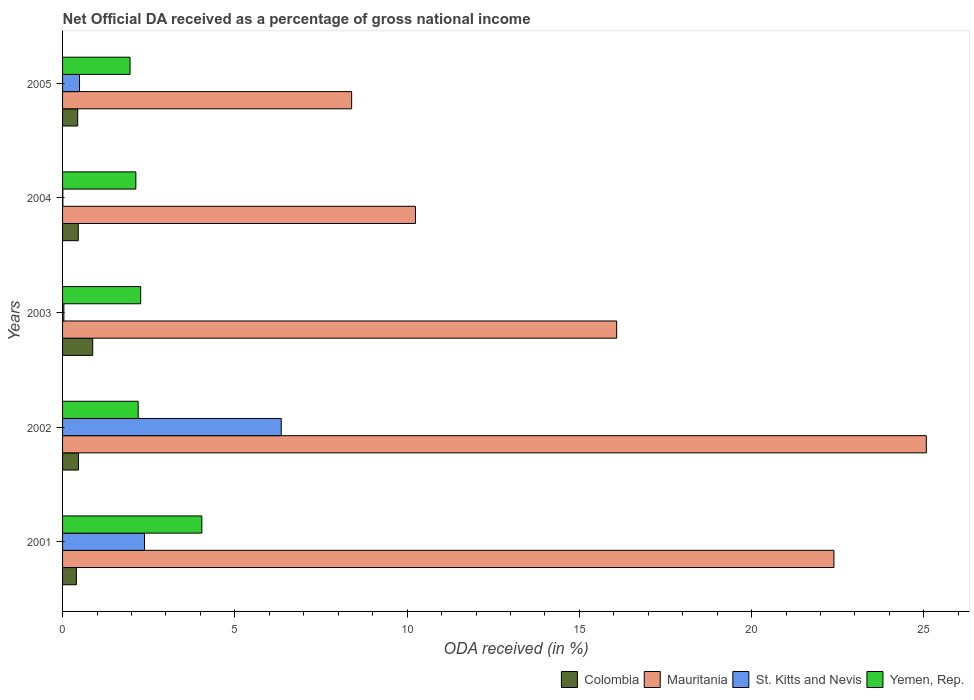How many different coloured bars are there?
Your answer should be very brief. 4. Are the number of bars per tick equal to the number of legend labels?
Provide a succinct answer. Yes. How many bars are there on the 3rd tick from the top?
Ensure brevity in your answer.  4. How many bars are there on the 4th tick from the bottom?
Your response must be concise. 4. What is the net official DA received in Yemen, Rep. in 2001?
Offer a very short reply. 4.04. Across all years, what is the maximum net official DA received in Mauritania?
Provide a succinct answer. 25.07. Across all years, what is the minimum net official DA received in Colombia?
Make the answer very short. 0.4. What is the total net official DA received in Colombia in the graph?
Offer a very short reply. 2.63. What is the difference between the net official DA received in Colombia in 2001 and that in 2002?
Keep it short and to the point. -0.06. What is the difference between the net official DA received in Mauritania in 2001 and the net official DA received in Yemen, Rep. in 2002?
Your answer should be very brief. 20.19. What is the average net official DA received in St. Kitts and Nevis per year?
Provide a succinct answer. 1.85. In the year 2005, what is the difference between the net official DA received in Mauritania and net official DA received in Yemen, Rep.?
Your answer should be compact. 6.43. What is the ratio of the net official DA received in Mauritania in 2001 to that in 2004?
Provide a succinct answer. 2.19. Is the difference between the net official DA received in Mauritania in 2004 and 2005 greater than the difference between the net official DA received in Yemen, Rep. in 2004 and 2005?
Your answer should be very brief. Yes. What is the difference between the highest and the second highest net official DA received in Yemen, Rep.?
Provide a succinct answer. 1.77. What is the difference between the highest and the lowest net official DA received in Mauritania?
Keep it short and to the point. 16.68. Is the sum of the net official DA received in St. Kitts and Nevis in 2003 and 2005 greater than the maximum net official DA received in Colombia across all years?
Ensure brevity in your answer.  No. What does the 4th bar from the top in 2005 represents?
Your response must be concise. Colombia. What does the 2nd bar from the bottom in 2003 represents?
Ensure brevity in your answer.  Mauritania. How many bars are there?
Provide a succinct answer. 20. Are the values on the major ticks of X-axis written in scientific E-notation?
Provide a succinct answer. No. Does the graph contain any zero values?
Your answer should be compact. No. Does the graph contain grids?
Provide a short and direct response. No. What is the title of the graph?
Give a very brief answer. Net Official DA received as a percentage of gross national income. Does "Sint Maarten (Dutch part)" appear as one of the legend labels in the graph?
Keep it short and to the point. No. What is the label or title of the X-axis?
Give a very brief answer. ODA received (in %). What is the label or title of the Y-axis?
Give a very brief answer. Years. What is the ODA received (in %) in Colombia in 2001?
Your answer should be very brief. 0.4. What is the ODA received (in %) in Mauritania in 2001?
Ensure brevity in your answer.  22.39. What is the ODA received (in %) of St. Kitts and Nevis in 2001?
Make the answer very short. 2.38. What is the ODA received (in %) of Yemen, Rep. in 2001?
Give a very brief answer. 4.04. What is the ODA received (in %) of Colombia in 2002?
Your answer should be compact. 0.46. What is the ODA received (in %) in Mauritania in 2002?
Provide a short and direct response. 25.07. What is the ODA received (in %) in St. Kitts and Nevis in 2002?
Your answer should be very brief. 6.35. What is the ODA received (in %) in Yemen, Rep. in 2002?
Your response must be concise. 2.19. What is the ODA received (in %) of Colombia in 2003?
Your answer should be very brief. 0.88. What is the ODA received (in %) of Mauritania in 2003?
Give a very brief answer. 16.08. What is the ODA received (in %) in St. Kitts and Nevis in 2003?
Provide a succinct answer. 0.04. What is the ODA received (in %) of Yemen, Rep. in 2003?
Ensure brevity in your answer.  2.27. What is the ODA received (in %) in Colombia in 2004?
Ensure brevity in your answer.  0.46. What is the ODA received (in %) in Mauritania in 2004?
Keep it short and to the point. 10.24. What is the ODA received (in %) of St. Kitts and Nevis in 2004?
Provide a succinct answer. 0.01. What is the ODA received (in %) of Yemen, Rep. in 2004?
Make the answer very short. 2.13. What is the ODA received (in %) of Colombia in 2005?
Give a very brief answer. 0.44. What is the ODA received (in %) of Mauritania in 2005?
Your answer should be very brief. 8.39. What is the ODA received (in %) of St. Kitts and Nevis in 2005?
Offer a terse response. 0.49. What is the ODA received (in %) in Yemen, Rep. in 2005?
Give a very brief answer. 1.96. Across all years, what is the maximum ODA received (in %) in Colombia?
Offer a very short reply. 0.88. Across all years, what is the maximum ODA received (in %) of Mauritania?
Your answer should be very brief. 25.07. Across all years, what is the maximum ODA received (in %) in St. Kitts and Nevis?
Your answer should be compact. 6.35. Across all years, what is the maximum ODA received (in %) in Yemen, Rep.?
Offer a terse response. 4.04. Across all years, what is the minimum ODA received (in %) of Colombia?
Offer a very short reply. 0.4. Across all years, what is the minimum ODA received (in %) in Mauritania?
Offer a terse response. 8.39. Across all years, what is the minimum ODA received (in %) in St. Kitts and Nevis?
Your answer should be very brief. 0.01. Across all years, what is the minimum ODA received (in %) of Yemen, Rep.?
Your answer should be compact. 1.96. What is the total ODA received (in %) in Colombia in the graph?
Keep it short and to the point. 2.63. What is the total ODA received (in %) of Mauritania in the graph?
Offer a very short reply. 82.17. What is the total ODA received (in %) in St. Kitts and Nevis in the graph?
Your response must be concise. 9.26. What is the total ODA received (in %) of Yemen, Rep. in the graph?
Your answer should be very brief. 12.59. What is the difference between the ODA received (in %) of Colombia in 2001 and that in 2002?
Make the answer very short. -0.06. What is the difference between the ODA received (in %) of Mauritania in 2001 and that in 2002?
Your answer should be compact. -2.68. What is the difference between the ODA received (in %) in St. Kitts and Nevis in 2001 and that in 2002?
Give a very brief answer. -3.97. What is the difference between the ODA received (in %) of Yemen, Rep. in 2001 and that in 2002?
Ensure brevity in your answer.  1.85. What is the difference between the ODA received (in %) of Colombia in 2001 and that in 2003?
Your answer should be compact. -0.47. What is the difference between the ODA received (in %) of Mauritania in 2001 and that in 2003?
Offer a very short reply. 6.31. What is the difference between the ODA received (in %) of St. Kitts and Nevis in 2001 and that in 2003?
Make the answer very short. 2.34. What is the difference between the ODA received (in %) of Yemen, Rep. in 2001 and that in 2003?
Offer a very short reply. 1.77. What is the difference between the ODA received (in %) in Colombia in 2001 and that in 2004?
Offer a terse response. -0.05. What is the difference between the ODA received (in %) in Mauritania in 2001 and that in 2004?
Give a very brief answer. 12.15. What is the difference between the ODA received (in %) in St. Kitts and Nevis in 2001 and that in 2004?
Provide a short and direct response. 2.37. What is the difference between the ODA received (in %) in Yemen, Rep. in 2001 and that in 2004?
Ensure brevity in your answer.  1.92. What is the difference between the ODA received (in %) of Colombia in 2001 and that in 2005?
Ensure brevity in your answer.  -0.04. What is the difference between the ODA received (in %) in Mauritania in 2001 and that in 2005?
Make the answer very short. 14. What is the difference between the ODA received (in %) in St. Kitts and Nevis in 2001 and that in 2005?
Your answer should be very brief. 1.89. What is the difference between the ODA received (in %) in Yemen, Rep. in 2001 and that in 2005?
Provide a short and direct response. 2.08. What is the difference between the ODA received (in %) in Colombia in 2002 and that in 2003?
Give a very brief answer. -0.42. What is the difference between the ODA received (in %) of Mauritania in 2002 and that in 2003?
Provide a succinct answer. 8.99. What is the difference between the ODA received (in %) in St. Kitts and Nevis in 2002 and that in 2003?
Offer a very short reply. 6.31. What is the difference between the ODA received (in %) in Yemen, Rep. in 2002 and that in 2003?
Offer a terse response. -0.07. What is the difference between the ODA received (in %) in Colombia in 2002 and that in 2004?
Your answer should be compact. 0. What is the difference between the ODA received (in %) of Mauritania in 2002 and that in 2004?
Your answer should be very brief. 14.83. What is the difference between the ODA received (in %) in St. Kitts and Nevis in 2002 and that in 2004?
Provide a short and direct response. 6.34. What is the difference between the ODA received (in %) of Yemen, Rep. in 2002 and that in 2004?
Keep it short and to the point. 0.07. What is the difference between the ODA received (in %) in Colombia in 2002 and that in 2005?
Ensure brevity in your answer.  0.02. What is the difference between the ODA received (in %) of Mauritania in 2002 and that in 2005?
Your answer should be compact. 16.68. What is the difference between the ODA received (in %) of St. Kitts and Nevis in 2002 and that in 2005?
Ensure brevity in your answer.  5.86. What is the difference between the ODA received (in %) in Yemen, Rep. in 2002 and that in 2005?
Your answer should be very brief. 0.24. What is the difference between the ODA received (in %) in Colombia in 2003 and that in 2004?
Provide a succinct answer. 0.42. What is the difference between the ODA received (in %) of Mauritania in 2003 and that in 2004?
Offer a very short reply. 5.84. What is the difference between the ODA received (in %) in St. Kitts and Nevis in 2003 and that in 2004?
Offer a very short reply. 0.03. What is the difference between the ODA received (in %) in Yemen, Rep. in 2003 and that in 2004?
Make the answer very short. 0.14. What is the difference between the ODA received (in %) in Colombia in 2003 and that in 2005?
Your response must be concise. 0.44. What is the difference between the ODA received (in %) in Mauritania in 2003 and that in 2005?
Provide a short and direct response. 7.69. What is the difference between the ODA received (in %) of St. Kitts and Nevis in 2003 and that in 2005?
Give a very brief answer. -0.45. What is the difference between the ODA received (in %) of Yemen, Rep. in 2003 and that in 2005?
Your response must be concise. 0.31. What is the difference between the ODA received (in %) of Colombia in 2004 and that in 2005?
Give a very brief answer. 0.02. What is the difference between the ODA received (in %) of Mauritania in 2004 and that in 2005?
Offer a very short reply. 1.85. What is the difference between the ODA received (in %) in St. Kitts and Nevis in 2004 and that in 2005?
Ensure brevity in your answer.  -0.48. What is the difference between the ODA received (in %) of Yemen, Rep. in 2004 and that in 2005?
Ensure brevity in your answer.  0.17. What is the difference between the ODA received (in %) of Colombia in 2001 and the ODA received (in %) of Mauritania in 2002?
Your answer should be compact. -24.67. What is the difference between the ODA received (in %) of Colombia in 2001 and the ODA received (in %) of St. Kitts and Nevis in 2002?
Keep it short and to the point. -5.95. What is the difference between the ODA received (in %) in Colombia in 2001 and the ODA received (in %) in Yemen, Rep. in 2002?
Provide a succinct answer. -1.79. What is the difference between the ODA received (in %) of Mauritania in 2001 and the ODA received (in %) of St. Kitts and Nevis in 2002?
Offer a very short reply. 16.04. What is the difference between the ODA received (in %) in Mauritania in 2001 and the ODA received (in %) in Yemen, Rep. in 2002?
Make the answer very short. 20.19. What is the difference between the ODA received (in %) of St. Kitts and Nevis in 2001 and the ODA received (in %) of Yemen, Rep. in 2002?
Offer a terse response. 0.18. What is the difference between the ODA received (in %) in Colombia in 2001 and the ODA received (in %) in Mauritania in 2003?
Offer a terse response. -15.68. What is the difference between the ODA received (in %) of Colombia in 2001 and the ODA received (in %) of St. Kitts and Nevis in 2003?
Your response must be concise. 0.36. What is the difference between the ODA received (in %) of Colombia in 2001 and the ODA received (in %) of Yemen, Rep. in 2003?
Give a very brief answer. -1.87. What is the difference between the ODA received (in %) in Mauritania in 2001 and the ODA received (in %) in St. Kitts and Nevis in 2003?
Your response must be concise. 22.35. What is the difference between the ODA received (in %) in Mauritania in 2001 and the ODA received (in %) in Yemen, Rep. in 2003?
Ensure brevity in your answer.  20.12. What is the difference between the ODA received (in %) of Colombia in 2001 and the ODA received (in %) of Mauritania in 2004?
Make the answer very short. -9.84. What is the difference between the ODA received (in %) of Colombia in 2001 and the ODA received (in %) of St. Kitts and Nevis in 2004?
Provide a short and direct response. 0.39. What is the difference between the ODA received (in %) of Colombia in 2001 and the ODA received (in %) of Yemen, Rep. in 2004?
Give a very brief answer. -1.73. What is the difference between the ODA received (in %) in Mauritania in 2001 and the ODA received (in %) in St. Kitts and Nevis in 2004?
Provide a succinct answer. 22.38. What is the difference between the ODA received (in %) in Mauritania in 2001 and the ODA received (in %) in Yemen, Rep. in 2004?
Offer a very short reply. 20.26. What is the difference between the ODA received (in %) of St. Kitts and Nevis in 2001 and the ODA received (in %) of Yemen, Rep. in 2004?
Provide a short and direct response. 0.25. What is the difference between the ODA received (in %) in Colombia in 2001 and the ODA received (in %) in Mauritania in 2005?
Your answer should be compact. -7.99. What is the difference between the ODA received (in %) of Colombia in 2001 and the ODA received (in %) of St. Kitts and Nevis in 2005?
Ensure brevity in your answer.  -0.09. What is the difference between the ODA received (in %) in Colombia in 2001 and the ODA received (in %) in Yemen, Rep. in 2005?
Offer a very short reply. -1.56. What is the difference between the ODA received (in %) of Mauritania in 2001 and the ODA received (in %) of St. Kitts and Nevis in 2005?
Offer a very short reply. 21.9. What is the difference between the ODA received (in %) in Mauritania in 2001 and the ODA received (in %) in Yemen, Rep. in 2005?
Provide a short and direct response. 20.43. What is the difference between the ODA received (in %) in St. Kitts and Nevis in 2001 and the ODA received (in %) in Yemen, Rep. in 2005?
Make the answer very short. 0.42. What is the difference between the ODA received (in %) of Colombia in 2002 and the ODA received (in %) of Mauritania in 2003?
Make the answer very short. -15.62. What is the difference between the ODA received (in %) in Colombia in 2002 and the ODA received (in %) in St. Kitts and Nevis in 2003?
Offer a terse response. 0.42. What is the difference between the ODA received (in %) in Colombia in 2002 and the ODA received (in %) in Yemen, Rep. in 2003?
Your answer should be compact. -1.81. What is the difference between the ODA received (in %) of Mauritania in 2002 and the ODA received (in %) of St. Kitts and Nevis in 2003?
Your answer should be very brief. 25.03. What is the difference between the ODA received (in %) in Mauritania in 2002 and the ODA received (in %) in Yemen, Rep. in 2003?
Provide a succinct answer. 22.8. What is the difference between the ODA received (in %) of St. Kitts and Nevis in 2002 and the ODA received (in %) of Yemen, Rep. in 2003?
Your response must be concise. 4.08. What is the difference between the ODA received (in %) of Colombia in 2002 and the ODA received (in %) of Mauritania in 2004?
Provide a succinct answer. -9.78. What is the difference between the ODA received (in %) of Colombia in 2002 and the ODA received (in %) of St. Kitts and Nevis in 2004?
Provide a short and direct response. 0.45. What is the difference between the ODA received (in %) in Colombia in 2002 and the ODA received (in %) in Yemen, Rep. in 2004?
Provide a short and direct response. -1.67. What is the difference between the ODA received (in %) of Mauritania in 2002 and the ODA received (in %) of St. Kitts and Nevis in 2004?
Ensure brevity in your answer.  25.06. What is the difference between the ODA received (in %) of Mauritania in 2002 and the ODA received (in %) of Yemen, Rep. in 2004?
Your response must be concise. 22.94. What is the difference between the ODA received (in %) in St. Kitts and Nevis in 2002 and the ODA received (in %) in Yemen, Rep. in 2004?
Provide a short and direct response. 4.22. What is the difference between the ODA received (in %) of Colombia in 2002 and the ODA received (in %) of Mauritania in 2005?
Keep it short and to the point. -7.93. What is the difference between the ODA received (in %) in Colombia in 2002 and the ODA received (in %) in St. Kitts and Nevis in 2005?
Your answer should be very brief. -0.03. What is the difference between the ODA received (in %) in Colombia in 2002 and the ODA received (in %) in Yemen, Rep. in 2005?
Ensure brevity in your answer.  -1.5. What is the difference between the ODA received (in %) of Mauritania in 2002 and the ODA received (in %) of St. Kitts and Nevis in 2005?
Your response must be concise. 24.58. What is the difference between the ODA received (in %) of Mauritania in 2002 and the ODA received (in %) of Yemen, Rep. in 2005?
Offer a very short reply. 23.11. What is the difference between the ODA received (in %) in St. Kitts and Nevis in 2002 and the ODA received (in %) in Yemen, Rep. in 2005?
Your answer should be compact. 4.39. What is the difference between the ODA received (in %) in Colombia in 2003 and the ODA received (in %) in Mauritania in 2004?
Your answer should be compact. -9.37. What is the difference between the ODA received (in %) of Colombia in 2003 and the ODA received (in %) of St. Kitts and Nevis in 2004?
Give a very brief answer. 0.87. What is the difference between the ODA received (in %) in Colombia in 2003 and the ODA received (in %) in Yemen, Rep. in 2004?
Ensure brevity in your answer.  -1.25. What is the difference between the ODA received (in %) in Mauritania in 2003 and the ODA received (in %) in St. Kitts and Nevis in 2004?
Give a very brief answer. 16.07. What is the difference between the ODA received (in %) of Mauritania in 2003 and the ODA received (in %) of Yemen, Rep. in 2004?
Offer a terse response. 13.96. What is the difference between the ODA received (in %) of St. Kitts and Nevis in 2003 and the ODA received (in %) of Yemen, Rep. in 2004?
Provide a short and direct response. -2.09. What is the difference between the ODA received (in %) in Colombia in 2003 and the ODA received (in %) in Mauritania in 2005?
Offer a terse response. -7.51. What is the difference between the ODA received (in %) of Colombia in 2003 and the ODA received (in %) of St. Kitts and Nevis in 2005?
Offer a terse response. 0.38. What is the difference between the ODA received (in %) in Colombia in 2003 and the ODA received (in %) in Yemen, Rep. in 2005?
Your answer should be compact. -1.08. What is the difference between the ODA received (in %) of Mauritania in 2003 and the ODA received (in %) of St. Kitts and Nevis in 2005?
Offer a very short reply. 15.59. What is the difference between the ODA received (in %) in Mauritania in 2003 and the ODA received (in %) in Yemen, Rep. in 2005?
Keep it short and to the point. 14.12. What is the difference between the ODA received (in %) in St. Kitts and Nevis in 2003 and the ODA received (in %) in Yemen, Rep. in 2005?
Offer a very short reply. -1.92. What is the difference between the ODA received (in %) of Colombia in 2004 and the ODA received (in %) of Mauritania in 2005?
Give a very brief answer. -7.93. What is the difference between the ODA received (in %) of Colombia in 2004 and the ODA received (in %) of St. Kitts and Nevis in 2005?
Your answer should be compact. -0.04. What is the difference between the ODA received (in %) in Colombia in 2004 and the ODA received (in %) in Yemen, Rep. in 2005?
Your response must be concise. -1.5. What is the difference between the ODA received (in %) in Mauritania in 2004 and the ODA received (in %) in St. Kitts and Nevis in 2005?
Your answer should be compact. 9.75. What is the difference between the ODA received (in %) in Mauritania in 2004 and the ODA received (in %) in Yemen, Rep. in 2005?
Provide a short and direct response. 8.28. What is the difference between the ODA received (in %) of St. Kitts and Nevis in 2004 and the ODA received (in %) of Yemen, Rep. in 2005?
Keep it short and to the point. -1.95. What is the average ODA received (in %) of Colombia per year?
Ensure brevity in your answer.  0.53. What is the average ODA received (in %) in Mauritania per year?
Offer a very short reply. 16.43. What is the average ODA received (in %) of St. Kitts and Nevis per year?
Offer a terse response. 1.85. What is the average ODA received (in %) of Yemen, Rep. per year?
Keep it short and to the point. 2.52. In the year 2001, what is the difference between the ODA received (in %) of Colombia and ODA received (in %) of Mauritania?
Your response must be concise. -21.99. In the year 2001, what is the difference between the ODA received (in %) in Colombia and ODA received (in %) in St. Kitts and Nevis?
Offer a terse response. -1.98. In the year 2001, what is the difference between the ODA received (in %) of Colombia and ODA received (in %) of Yemen, Rep.?
Ensure brevity in your answer.  -3.64. In the year 2001, what is the difference between the ODA received (in %) in Mauritania and ODA received (in %) in St. Kitts and Nevis?
Keep it short and to the point. 20.01. In the year 2001, what is the difference between the ODA received (in %) in Mauritania and ODA received (in %) in Yemen, Rep.?
Offer a very short reply. 18.35. In the year 2001, what is the difference between the ODA received (in %) in St. Kitts and Nevis and ODA received (in %) in Yemen, Rep.?
Keep it short and to the point. -1.66. In the year 2002, what is the difference between the ODA received (in %) in Colombia and ODA received (in %) in Mauritania?
Provide a short and direct response. -24.61. In the year 2002, what is the difference between the ODA received (in %) of Colombia and ODA received (in %) of St. Kitts and Nevis?
Your response must be concise. -5.89. In the year 2002, what is the difference between the ODA received (in %) in Colombia and ODA received (in %) in Yemen, Rep.?
Make the answer very short. -1.73. In the year 2002, what is the difference between the ODA received (in %) in Mauritania and ODA received (in %) in St. Kitts and Nevis?
Give a very brief answer. 18.72. In the year 2002, what is the difference between the ODA received (in %) in Mauritania and ODA received (in %) in Yemen, Rep.?
Provide a succinct answer. 22.88. In the year 2002, what is the difference between the ODA received (in %) of St. Kitts and Nevis and ODA received (in %) of Yemen, Rep.?
Make the answer very short. 4.15. In the year 2003, what is the difference between the ODA received (in %) in Colombia and ODA received (in %) in Mauritania?
Your answer should be very brief. -15.21. In the year 2003, what is the difference between the ODA received (in %) of Colombia and ODA received (in %) of St. Kitts and Nevis?
Ensure brevity in your answer.  0.84. In the year 2003, what is the difference between the ODA received (in %) of Colombia and ODA received (in %) of Yemen, Rep.?
Provide a short and direct response. -1.39. In the year 2003, what is the difference between the ODA received (in %) in Mauritania and ODA received (in %) in St. Kitts and Nevis?
Provide a short and direct response. 16.04. In the year 2003, what is the difference between the ODA received (in %) in Mauritania and ODA received (in %) in Yemen, Rep.?
Make the answer very short. 13.81. In the year 2003, what is the difference between the ODA received (in %) in St. Kitts and Nevis and ODA received (in %) in Yemen, Rep.?
Provide a short and direct response. -2.23. In the year 2004, what is the difference between the ODA received (in %) of Colombia and ODA received (in %) of Mauritania?
Make the answer very short. -9.79. In the year 2004, what is the difference between the ODA received (in %) in Colombia and ODA received (in %) in St. Kitts and Nevis?
Provide a short and direct response. 0.45. In the year 2004, what is the difference between the ODA received (in %) of Colombia and ODA received (in %) of Yemen, Rep.?
Provide a succinct answer. -1.67. In the year 2004, what is the difference between the ODA received (in %) in Mauritania and ODA received (in %) in St. Kitts and Nevis?
Keep it short and to the point. 10.23. In the year 2004, what is the difference between the ODA received (in %) in Mauritania and ODA received (in %) in Yemen, Rep.?
Make the answer very short. 8.12. In the year 2004, what is the difference between the ODA received (in %) in St. Kitts and Nevis and ODA received (in %) in Yemen, Rep.?
Your answer should be compact. -2.12. In the year 2005, what is the difference between the ODA received (in %) of Colombia and ODA received (in %) of Mauritania?
Keep it short and to the point. -7.95. In the year 2005, what is the difference between the ODA received (in %) of Colombia and ODA received (in %) of St. Kitts and Nevis?
Ensure brevity in your answer.  -0.05. In the year 2005, what is the difference between the ODA received (in %) in Colombia and ODA received (in %) in Yemen, Rep.?
Your answer should be very brief. -1.52. In the year 2005, what is the difference between the ODA received (in %) in Mauritania and ODA received (in %) in St. Kitts and Nevis?
Give a very brief answer. 7.9. In the year 2005, what is the difference between the ODA received (in %) in Mauritania and ODA received (in %) in Yemen, Rep.?
Your answer should be very brief. 6.43. In the year 2005, what is the difference between the ODA received (in %) in St. Kitts and Nevis and ODA received (in %) in Yemen, Rep.?
Offer a terse response. -1.47. What is the ratio of the ODA received (in %) in Colombia in 2001 to that in 2002?
Provide a succinct answer. 0.87. What is the ratio of the ODA received (in %) in Mauritania in 2001 to that in 2002?
Your answer should be compact. 0.89. What is the ratio of the ODA received (in %) of St. Kitts and Nevis in 2001 to that in 2002?
Your answer should be very brief. 0.37. What is the ratio of the ODA received (in %) in Yemen, Rep. in 2001 to that in 2002?
Offer a terse response. 1.84. What is the ratio of the ODA received (in %) of Colombia in 2001 to that in 2003?
Offer a very short reply. 0.46. What is the ratio of the ODA received (in %) of Mauritania in 2001 to that in 2003?
Your answer should be very brief. 1.39. What is the ratio of the ODA received (in %) in St. Kitts and Nevis in 2001 to that in 2003?
Offer a very short reply. 62.39. What is the ratio of the ODA received (in %) in Yemen, Rep. in 2001 to that in 2003?
Your answer should be very brief. 1.78. What is the ratio of the ODA received (in %) of Colombia in 2001 to that in 2004?
Ensure brevity in your answer.  0.88. What is the ratio of the ODA received (in %) in Mauritania in 2001 to that in 2004?
Your response must be concise. 2.19. What is the ratio of the ODA received (in %) of St. Kitts and Nevis in 2001 to that in 2004?
Make the answer very short. 274.9. What is the ratio of the ODA received (in %) in Yemen, Rep. in 2001 to that in 2004?
Offer a terse response. 1.9. What is the ratio of the ODA received (in %) in Colombia in 2001 to that in 2005?
Provide a short and direct response. 0.91. What is the ratio of the ODA received (in %) in Mauritania in 2001 to that in 2005?
Offer a very short reply. 2.67. What is the ratio of the ODA received (in %) of St. Kitts and Nevis in 2001 to that in 2005?
Your answer should be compact. 4.83. What is the ratio of the ODA received (in %) in Yemen, Rep. in 2001 to that in 2005?
Offer a terse response. 2.06. What is the ratio of the ODA received (in %) of Colombia in 2002 to that in 2003?
Provide a succinct answer. 0.53. What is the ratio of the ODA received (in %) in Mauritania in 2002 to that in 2003?
Keep it short and to the point. 1.56. What is the ratio of the ODA received (in %) in St. Kitts and Nevis in 2002 to that in 2003?
Make the answer very short. 166.46. What is the ratio of the ODA received (in %) in Yemen, Rep. in 2002 to that in 2003?
Keep it short and to the point. 0.97. What is the ratio of the ODA received (in %) in Colombia in 2002 to that in 2004?
Keep it short and to the point. 1.01. What is the ratio of the ODA received (in %) of Mauritania in 2002 to that in 2004?
Your response must be concise. 2.45. What is the ratio of the ODA received (in %) in St. Kitts and Nevis in 2002 to that in 2004?
Keep it short and to the point. 733.48. What is the ratio of the ODA received (in %) of Yemen, Rep. in 2002 to that in 2004?
Your answer should be compact. 1.03. What is the ratio of the ODA received (in %) in Colombia in 2002 to that in 2005?
Offer a terse response. 1.05. What is the ratio of the ODA received (in %) in Mauritania in 2002 to that in 2005?
Your answer should be compact. 2.99. What is the ratio of the ODA received (in %) of St. Kitts and Nevis in 2002 to that in 2005?
Offer a very short reply. 12.9. What is the ratio of the ODA received (in %) in Yemen, Rep. in 2002 to that in 2005?
Your answer should be very brief. 1.12. What is the ratio of the ODA received (in %) of Colombia in 2003 to that in 2004?
Your response must be concise. 1.92. What is the ratio of the ODA received (in %) in Mauritania in 2003 to that in 2004?
Make the answer very short. 1.57. What is the ratio of the ODA received (in %) in St. Kitts and Nevis in 2003 to that in 2004?
Make the answer very short. 4.41. What is the ratio of the ODA received (in %) in Yemen, Rep. in 2003 to that in 2004?
Your answer should be compact. 1.07. What is the ratio of the ODA received (in %) of Colombia in 2003 to that in 2005?
Offer a terse response. 1.99. What is the ratio of the ODA received (in %) in Mauritania in 2003 to that in 2005?
Your response must be concise. 1.92. What is the ratio of the ODA received (in %) of St. Kitts and Nevis in 2003 to that in 2005?
Offer a terse response. 0.08. What is the ratio of the ODA received (in %) in Yemen, Rep. in 2003 to that in 2005?
Your answer should be compact. 1.16. What is the ratio of the ODA received (in %) of Colombia in 2004 to that in 2005?
Offer a very short reply. 1.04. What is the ratio of the ODA received (in %) in Mauritania in 2004 to that in 2005?
Offer a very short reply. 1.22. What is the ratio of the ODA received (in %) of St. Kitts and Nevis in 2004 to that in 2005?
Offer a terse response. 0.02. What is the ratio of the ODA received (in %) of Yemen, Rep. in 2004 to that in 2005?
Ensure brevity in your answer.  1.09. What is the difference between the highest and the second highest ODA received (in %) in Colombia?
Give a very brief answer. 0.42. What is the difference between the highest and the second highest ODA received (in %) in Mauritania?
Offer a very short reply. 2.68. What is the difference between the highest and the second highest ODA received (in %) in St. Kitts and Nevis?
Ensure brevity in your answer.  3.97. What is the difference between the highest and the second highest ODA received (in %) in Yemen, Rep.?
Provide a succinct answer. 1.77. What is the difference between the highest and the lowest ODA received (in %) of Colombia?
Make the answer very short. 0.47. What is the difference between the highest and the lowest ODA received (in %) in Mauritania?
Your answer should be very brief. 16.68. What is the difference between the highest and the lowest ODA received (in %) in St. Kitts and Nevis?
Provide a succinct answer. 6.34. What is the difference between the highest and the lowest ODA received (in %) in Yemen, Rep.?
Keep it short and to the point. 2.08. 